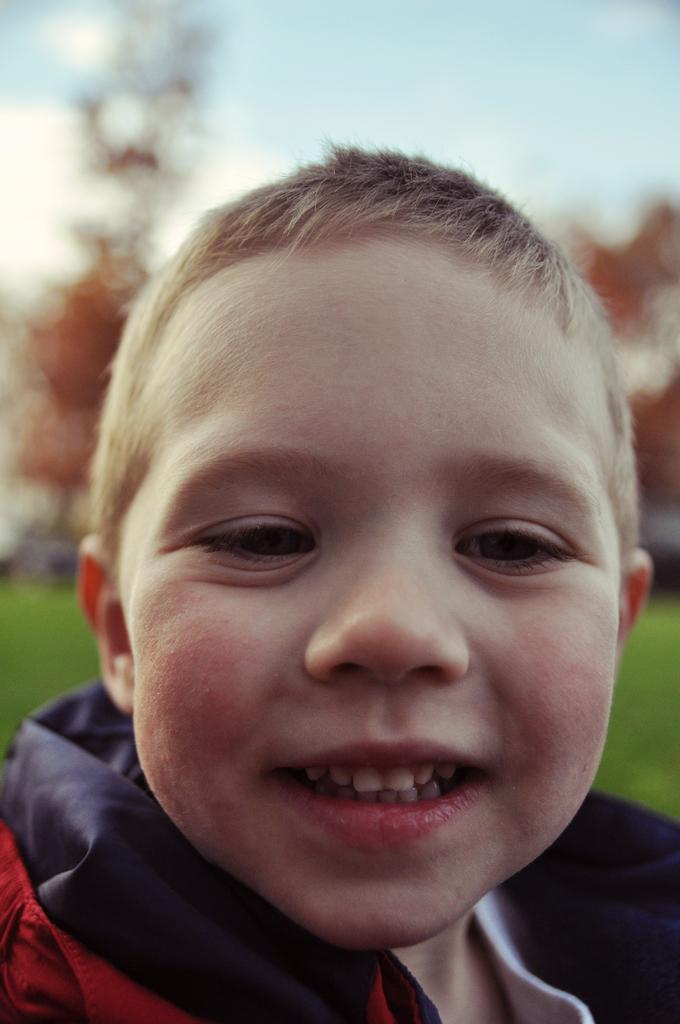What is the main subject of the image? There is a child in the image. Can you describe the child's clothing? The child is wearing a dress with red, black, and white colors. How would you describe the background of the image? The background of the image is blurry. What can be seen in the background of the image? The sky is visible in the background of the image. How many cacti are present in the image? There are no cacti present in the image. Can you hear the child laughing in the image? The image is silent, so we cannot hear the child laughing. 